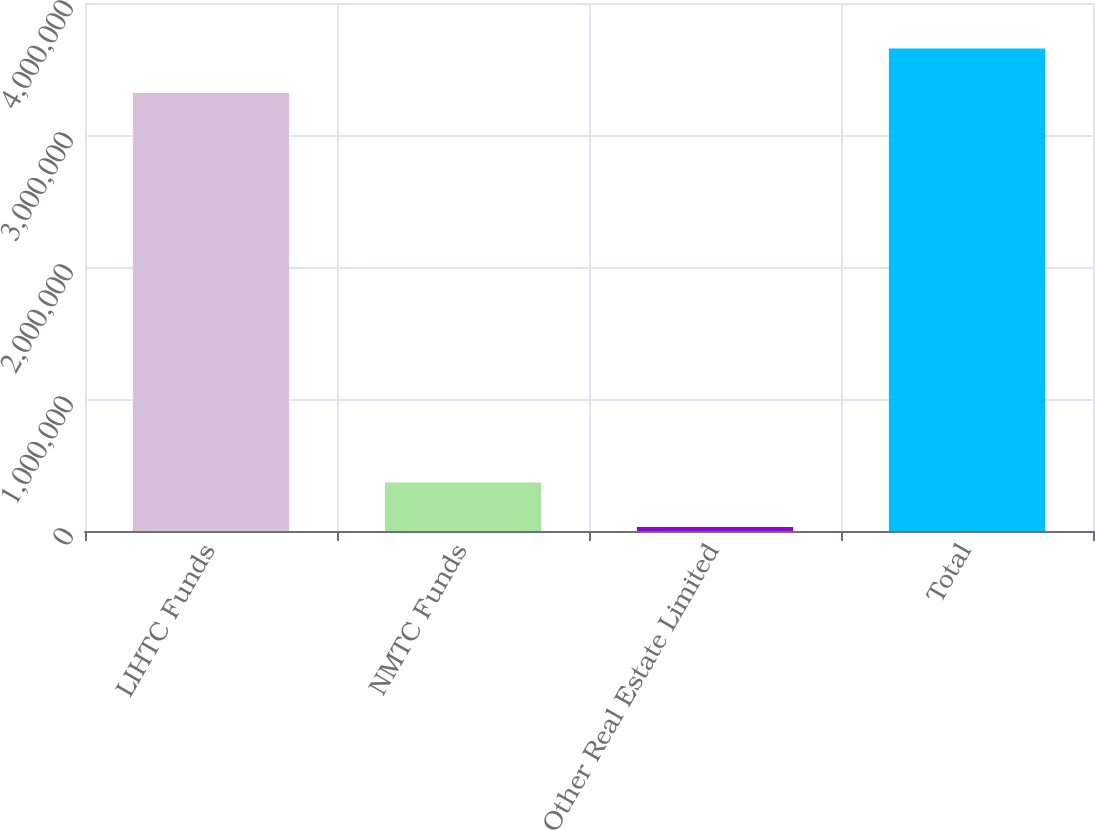<chart> <loc_0><loc_0><loc_500><loc_500><bar_chart><fcel>LIHTC Funds<fcel>NMTC Funds<fcel>Other Real Estate Limited<fcel>Total<nl><fcel>3.31759e+06<fcel>367821<fcel>29523<fcel>3.65589e+06<nl></chart> 